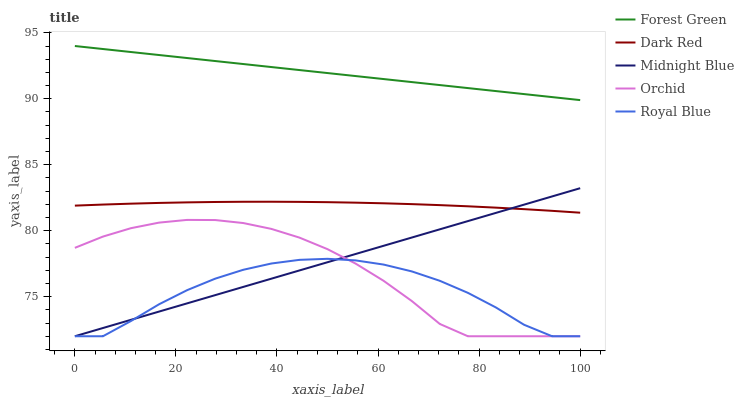Does Midnight Blue have the minimum area under the curve?
Answer yes or no. No. Does Midnight Blue have the maximum area under the curve?
Answer yes or no. No. Is Midnight Blue the smoothest?
Answer yes or no. No. Is Midnight Blue the roughest?
Answer yes or no. No. Does Forest Green have the lowest value?
Answer yes or no. No. Does Midnight Blue have the highest value?
Answer yes or no. No. Is Dark Red less than Forest Green?
Answer yes or no. Yes. Is Forest Green greater than Royal Blue?
Answer yes or no. Yes. Does Dark Red intersect Forest Green?
Answer yes or no. No. 